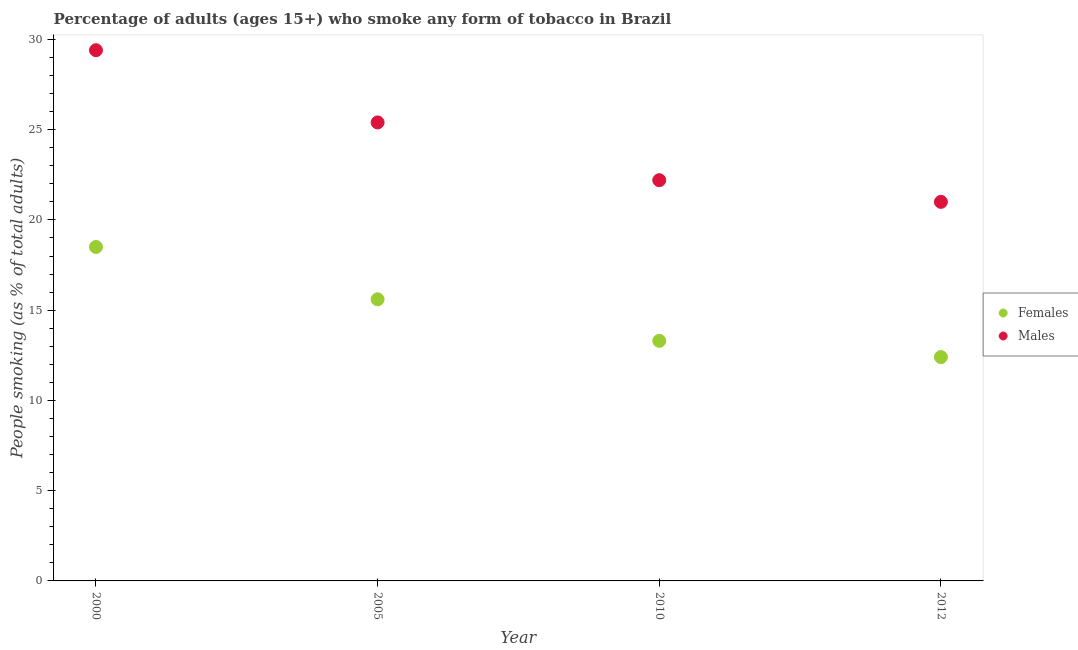How many different coloured dotlines are there?
Provide a short and direct response. 2. Is the number of dotlines equal to the number of legend labels?
Your answer should be compact. Yes. What is the percentage of males who smoke in 2005?
Offer a terse response. 25.4. Across all years, what is the maximum percentage of males who smoke?
Ensure brevity in your answer.  29.4. In which year was the percentage of females who smoke minimum?
Provide a succinct answer. 2012. What is the total percentage of males who smoke in the graph?
Your answer should be compact. 98. What is the difference between the percentage of males who smoke in 2000 and that in 2012?
Make the answer very short. 8.4. What is the difference between the percentage of females who smoke in 2010 and the percentage of males who smoke in 2000?
Offer a very short reply. -16.1. In the year 2012, what is the difference between the percentage of females who smoke and percentage of males who smoke?
Provide a succinct answer. -8.6. In how many years, is the percentage of males who smoke greater than 15 %?
Provide a short and direct response. 4. What is the ratio of the percentage of females who smoke in 2000 to that in 2005?
Provide a short and direct response. 1.19. Is the difference between the percentage of females who smoke in 2000 and 2012 greater than the difference between the percentage of males who smoke in 2000 and 2012?
Provide a short and direct response. No. What is the difference between the highest and the second highest percentage of males who smoke?
Keep it short and to the point. 4. In how many years, is the percentage of females who smoke greater than the average percentage of females who smoke taken over all years?
Offer a terse response. 2. Is the percentage of males who smoke strictly less than the percentage of females who smoke over the years?
Keep it short and to the point. No. How many dotlines are there?
Your answer should be very brief. 2. How many years are there in the graph?
Keep it short and to the point. 4. Are the values on the major ticks of Y-axis written in scientific E-notation?
Keep it short and to the point. No. How many legend labels are there?
Make the answer very short. 2. How are the legend labels stacked?
Provide a succinct answer. Vertical. What is the title of the graph?
Give a very brief answer. Percentage of adults (ages 15+) who smoke any form of tobacco in Brazil. What is the label or title of the Y-axis?
Give a very brief answer. People smoking (as % of total adults). What is the People smoking (as % of total adults) in Females in 2000?
Offer a very short reply. 18.5. What is the People smoking (as % of total adults) of Males in 2000?
Provide a succinct answer. 29.4. What is the People smoking (as % of total adults) of Females in 2005?
Provide a short and direct response. 15.6. What is the People smoking (as % of total adults) of Males in 2005?
Provide a short and direct response. 25.4. What is the People smoking (as % of total adults) of Females in 2010?
Provide a succinct answer. 13.3. Across all years, what is the maximum People smoking (as % of total adults) in Females?
Offer a very short reply. 18.5. Across all years, what is the maximum People smoking (as % of total adults) of Males?
Give a very brief answer. 29.4. Across all years, what is the minimum People smoking (as % of total adults) of Males?
Keep it short and to the point. 21. What is the total People smoking (as % of total adults) in Females in the graph?
Offer a terse response. 59.8. What is the difference between the People smoking (as % of total adults) in Males in 2000 and that in 2005?
Your answer should be very brief. 4. What is the difference between the People smoking (as % of total adults) in Males in 2000 and that in 2012?
Your answer should be compact. 8.4. What is the difference between the People smoking (as % of total adults) of Males in 2005 and that in 2010?
Provide a short and direct response. 3.2. What is the difference between the People smoking (as % of total adults) of Males in 2005 and that in 2012?
Ensure brevity in your answer.  4.4. What is the difference between the People smoking (as % of total adults) of Females in 2000 and the People smoking (as % of total adults) of Males in 2005?
Provide a short and direct response. -6.9. What is the difference between the People smoking (as % of total adults) in Females in 2000 and the People smoking (as % of total adults) in Males in 2010?
Make the answer very short. -3.7. What is the difference between the People smoking (as % of total adults) in Females in 2005 and the People smoking (as % of total adults) in Males in 2010?
Provide a short and direct response. -6.6. What is the difference between the People smoking (as % of total adults) in Females in 2005 and the People smoking (as % of total adults) in Males in 2012?
Your answer should be very brief. -5.4. What is the average People smoking (as % of total adults) in Females per year?
Your answer should be compact. 14.95. What is the average People smoking (as % of total adults) of Males per year?
Provide a short and direct response. 24.5. In the year 2005, what is the difference between the People smoking (as % of total adults) of Females and People smoking (as % of total adults) of Males?
Keep it short and to the point. -9.8. In the year 2012, what is the difference between the People smoking (as % of total adults) in Females and People smoking (as % of total adults) in Males?
Offer a very short reply. -8.6. What is the ratio of the People smoking (as % of total adults) in Females in 2000 to that in 2005?
Your response must be concise. 1.19. What is the ratio of the People smoking (as % of total adults) of Males in 2000 to that in 2005?
Provide a short and direct response. 1.16. What is the ratio of the People smoking (as % of total adults) of Females in 2000 to that in 2010?
Offer a very short reply. 1.39. What is the ratio of the People smoking (as % of total adults) in Males in 2000 to that in 2010?
Offer a very short reply. 1.32. What is the ratio of the People smoking (as % of total adults) of Females in 2000 to that in 2012?
Your answer should be very brief. 1.49. What is the ratio of the People smoking (as % of total adults) in Females in 2005 to that in 2010?
Your response must be concise. 1.17. What is the ratio of the People smoking (as % of total adults) of Males in 2005 to that in 2010?
Offer a terse response. 1.14. What is the ratio of the People smoking (as % of total adults) in Females in 2005 to that in 2012?
Keep it short and to the point. 1.26. What is the ratio of the People smoking (as % of total adults) in Males in 2005 to that in 2012?
Your answer should be compact. 1.21. What is the ratio of the People smoking (as % of total adults) in Females in 2010 to that in 2012?
Provide a short and direct response. 1.07. What is the ratio of the People smoking (as % of total adults) of Males in 2010 to that in 2012?
Your response must be concise. 1.06. What is the difference between the highest and the second highest People smoking (as % of total adults) in Males?
Your response must be concise. 4. What is the difference between the highest and the lowest People smoking (as % of total adults) in Males?
Provide a succinct answer. 8.4. 